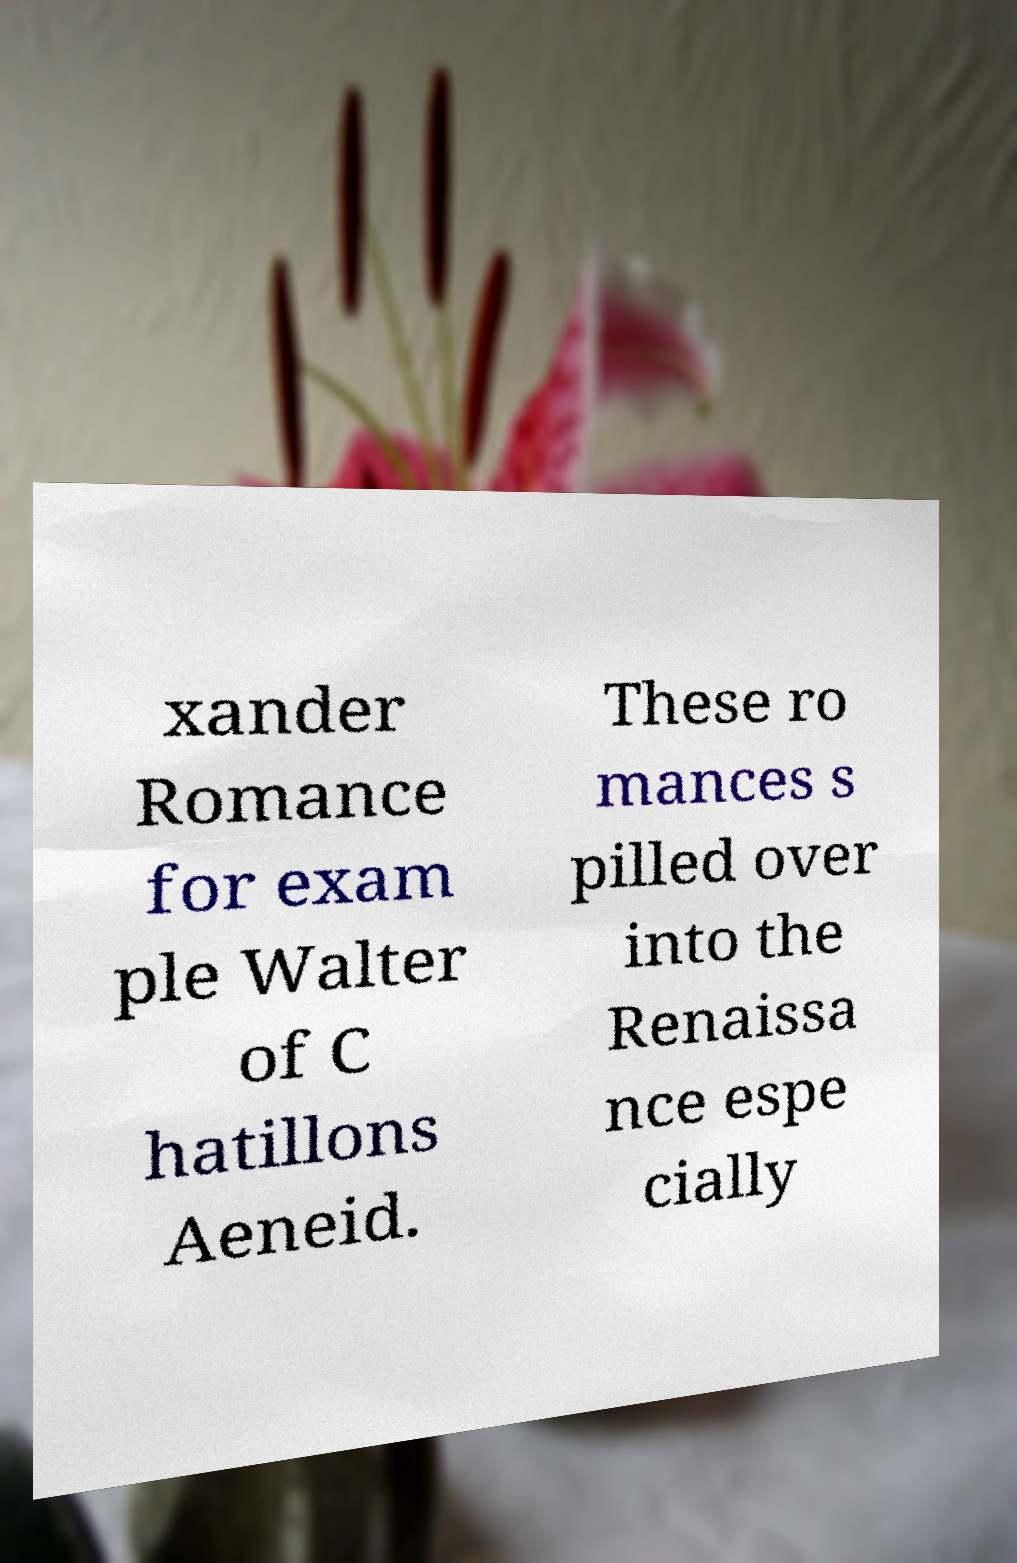For documentation purposes, I need the text within this image transcribed. Could you provide that? xander Romance for exam ple Walter of C hatillons Aeneid. These ro mances s pilled over into the Renaissa nce espe cially 